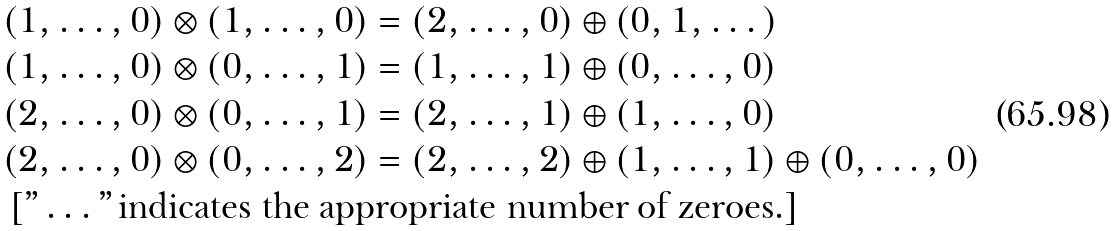<formula> <loc_0><loc_0><loc_500><loc_500>& ( 1 , \dots , 0 ) \otimes ( 1 , \dots , 0 ) = ( 2 , \dots , 0 ) \oplus ( 0 , 1 , \dots ) \\ & ( 1 , \dots , 0 ) \otimes ( 0 , \dots , 1 ) = ( 1 , \dots , 1 ) \oplus ( 0 , \dots , 0 ) \\ & ( 2 , \dots , 0 ) \otimes ( 0 , \dots , 1 ) = ( 2 , \dots , 1 ) \oplus ( 1 , \dots , 0 ) \\ & ( 2 , \dots , 0 ) \otimes ( 0 , \dots , 2 ) = ( 2 , \dots , 2 ) \oplus ( 1 , \dots , 1 ) \oplus ( 0 , \dots , 0 ) \\ & \left [ " \dots " \, \text {indicates the appropriate number of zeroes.} \right ]</formula> 